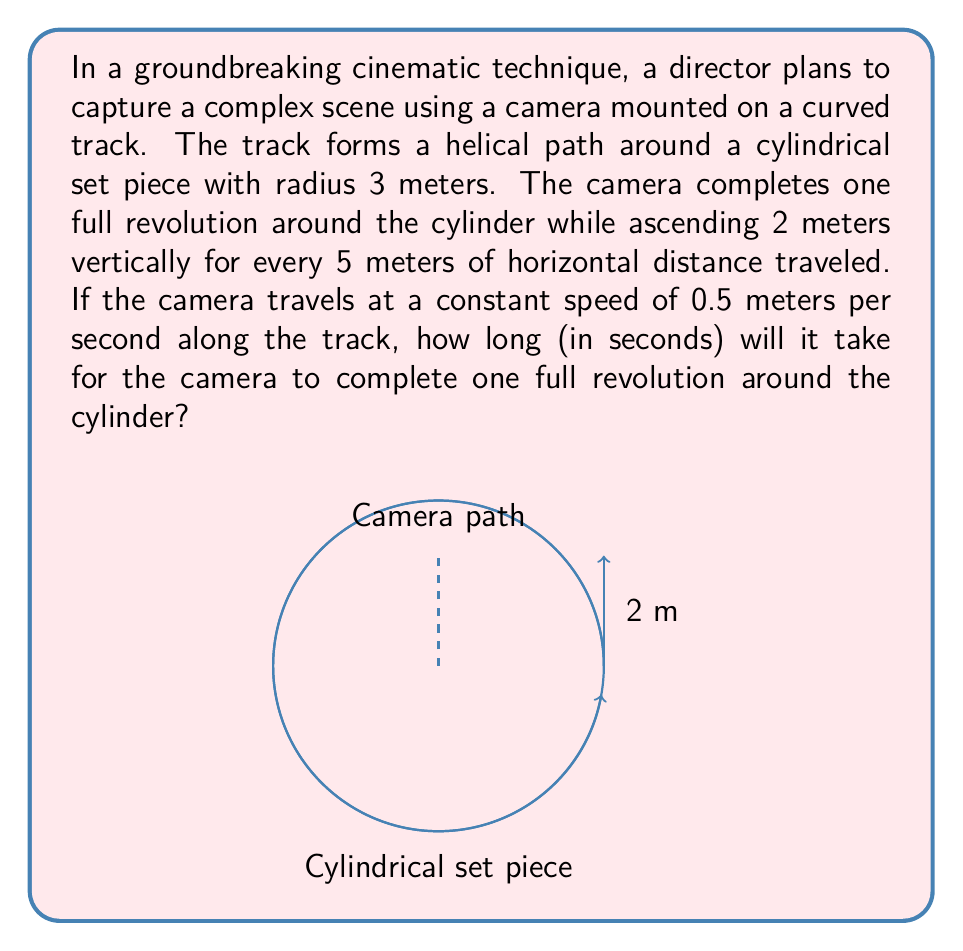Can you solve this math problem? Let's approach this step-by-step:

1) First, we need to understand the path of the camera. It's moving on a helix, which can be parameterized in cylindrical coordinates as:

   $$(r\cos\theta, r\sin\theta, h\theta/(2\pi))$$

   where $r$ is the radius of the cylinder, $h$ is the height gained in one revolution, and $\theta$ goes from 0 to $2\pi$ for one full revolution.

2) We're given that $r = 3$ meters and $h = 2$ meters.

3) To find the length of the path, we need to calculate the arc length of the helix for one revolution. The formula for the arc length of a helix is:

   $$L = \sqrt{(2\pi r)^2 + h^2}$$

4) Plugging in our values:

   $$L = \sqrt{(2\pi \cdot 3)^2 + 2^2} = \sqrt{355.3058...} \approx 18.8495 \text{ meters}$$

5) Now, we know that the camera is traveling at a constant speed of 0.5 meters per second. To find the time taken, we use the formula:

   $$\text{Time} = \frac{\text{Distance}}{\text{Speed}}$$

6) Plugging in our values:

   $$\text{Time} = \frac{18.8495}{0.5} = 37.699 \text{ seconds}$$

Therefore, it will take approximately 37.7 seconds for the camera to complete one full revolution.
Answer: 37.7 seconds 